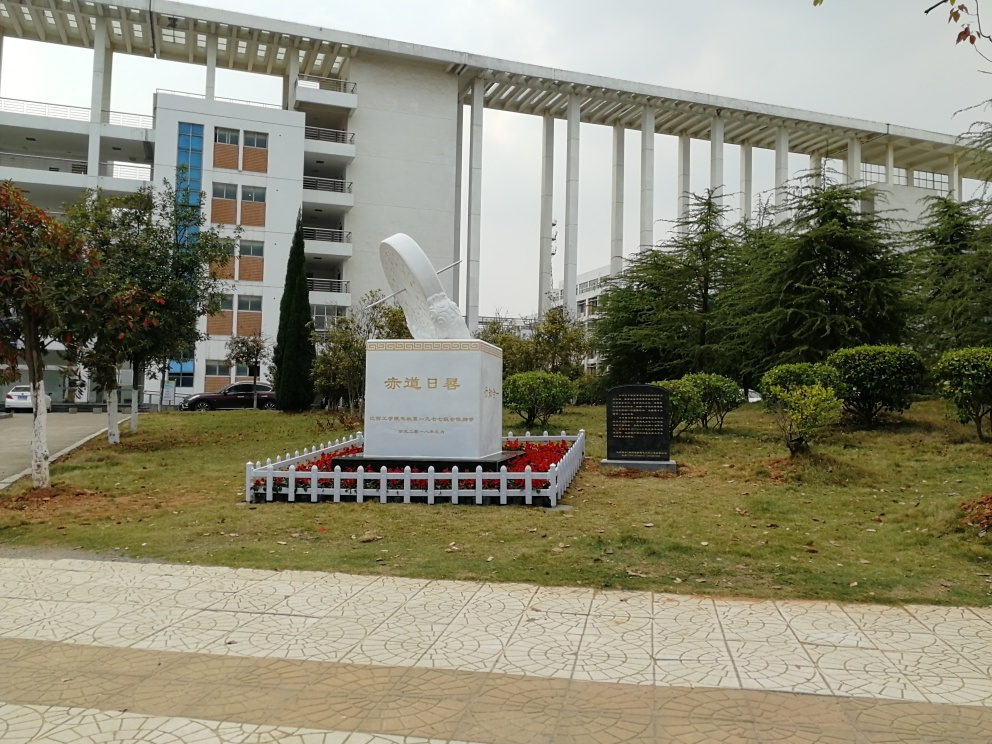Can you describe the monument in the foreground? Certainly! The monument in the image is quite prominent and appears to be a commemorative structure. It has what looks like a large sculpture resembling a feather or quill standing vertically on a plinth engraved with characters, likely indicating its significance or dedication. The pristine white color stands out against the greenery and there's a protective railing around it, suggesting it's an important landmark. 